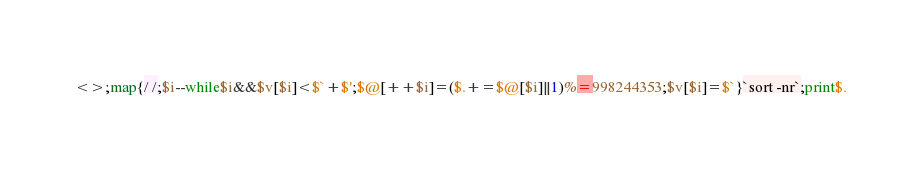Convert code to text. <code><loc_0><loc_0><loc_500><loc_500><_Perl_><>;map{/ /;$i--while$i&&$v[$i]<$`+$';$@[++$i]=($.+=$@[$i]||1)%=998244353;$v[$i]=$`}`sort -nr`;print$.</code> 